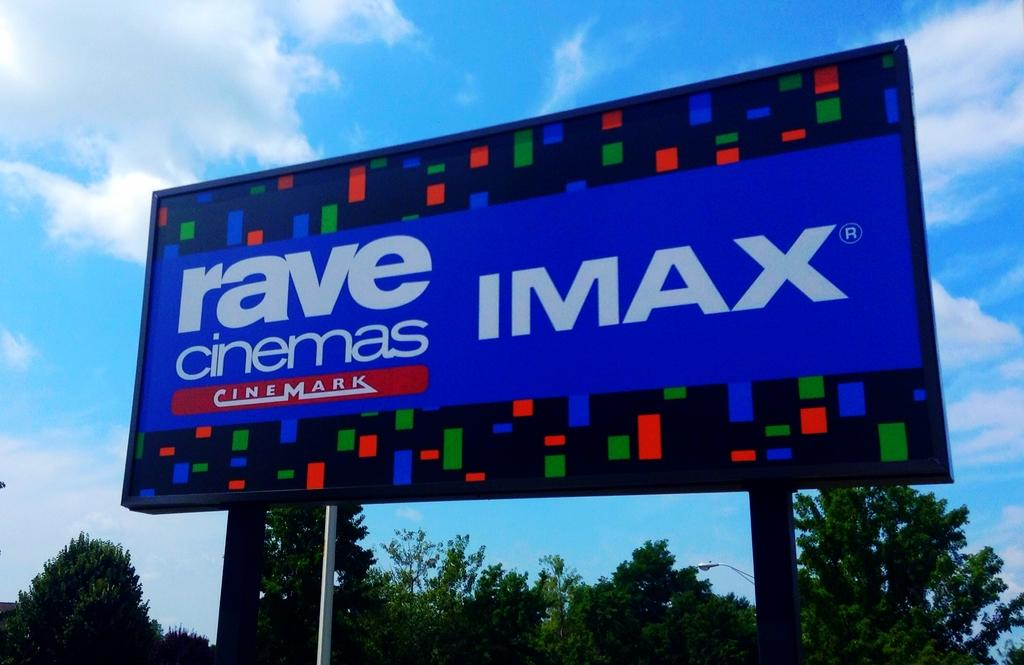Where was the image taken? The image was clicked outside. What is the main feature in the center of the image? There is a banner with text in the center of the image. How is the banner supported? The banner is attached to metal rods. What can be seen in the background of the image? The sky, trees, and a street light are visible in the background of the image. What type of wood is used to make the balls in the image? There are no balls present in the image, so it is not possible to determine the type of wood used to make them. 